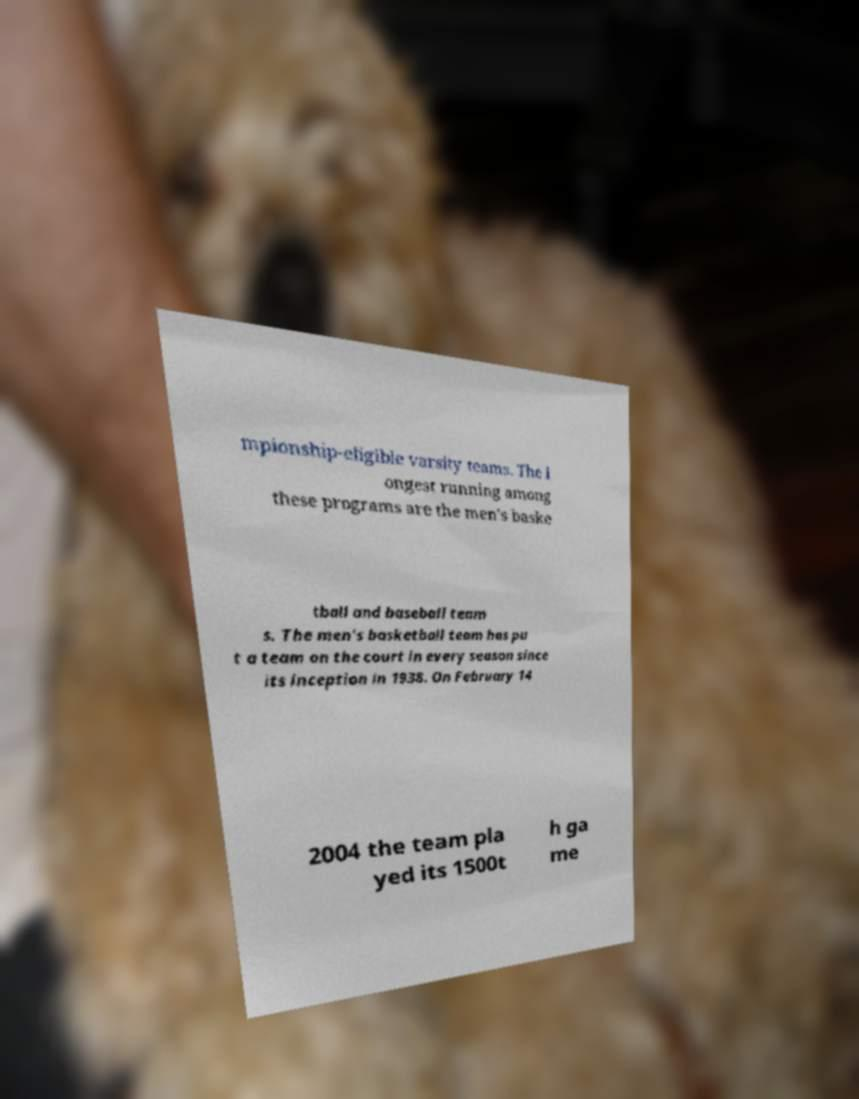Could you extract and type out the text from this image? mpionship-eligible varsity teams. The l ongest running among these programs are the men's baske tball and baseball team s. The men's basketball team has pu t a team on the court in every season since its inception in 1938. On February 14 2004 the team pla yed its 1500t h ga me 